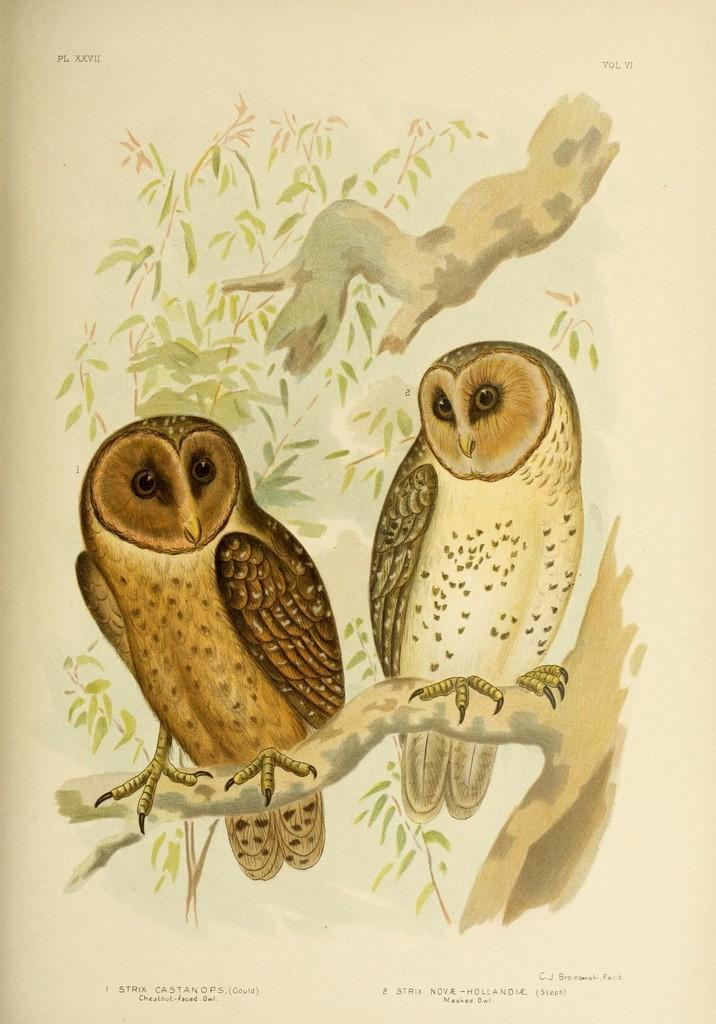What is the medium of the image? The image might be a painting on paper. How many owls are present in the image? There are two owls in the image. What are the owls doing in the image? The owls are holding a tree trunk in the image. What can be seen in the background of the image? There are trees visible in the background of the image. How many snakes are slithering around the owls in the image? There are no snakes present in the image; it features two owls holding a tree trunk and trees in the background. What message is the owl trying to convey through its writing in the image? There is no writing present in the image; it is a painting of two owls holding a tree trunk and trees in the background. 